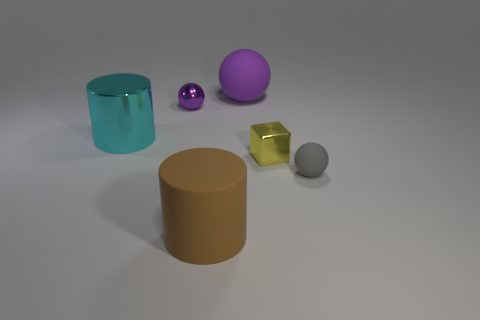How many other things are the same shape as the large cyan metallic object?
Provide a short and direct response. 1. How many yellow objects are small matte things or small shiny balls?
Give a very brief answer. 0. What material is the small purple object that is the same shape as the gray matte thing?
Keep it short and to the point. Metal. There is a gray thing on the right side of the brown matte cylinder; what shape is it?
Offer a terse response. Sphere. Is there a object made of the same material as the yellow cube?
Offer a terse response. Yes. Is the size of the yellow shiny thing the same as the cyan thing?
Ensure brevity in your answer.  No. How many cylinders are small blue rubber objects or large metallic objects?
Provide a short and direct response. 1. What is the material of the object that is the same color as the large matte sphere?
Provide a succinct answer. Metal. What number of small purple things have the same shape as the gray thing?
Your answer should be very brief. 1. Is the number of large things right of the big cyan metal cylinder greater than the number of big cyan shiny things that are in front of the large brown object?
Keep it short and to the point. Yes. 